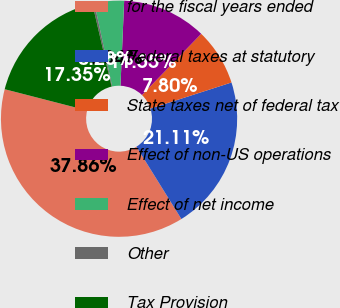Convert chart to OTSL. <chart><loc_0><loc_0><loc_500><loc_500><pie_chart><fcel>for the fiscal years ended<fcel>Federal taxes at statutory<fcel>State taxes net of federal tax<fcel>Effect of non-US operations<fcel>Effect of net income<fcel>Other<fcel>Tax Provision<nl><fcel>37.86%<fcel>21.11%<fcel>7.8%<fcel>11.55%<fcel>4.04%<fcel>0.28%<fcel>17.35%<nl></chart> 